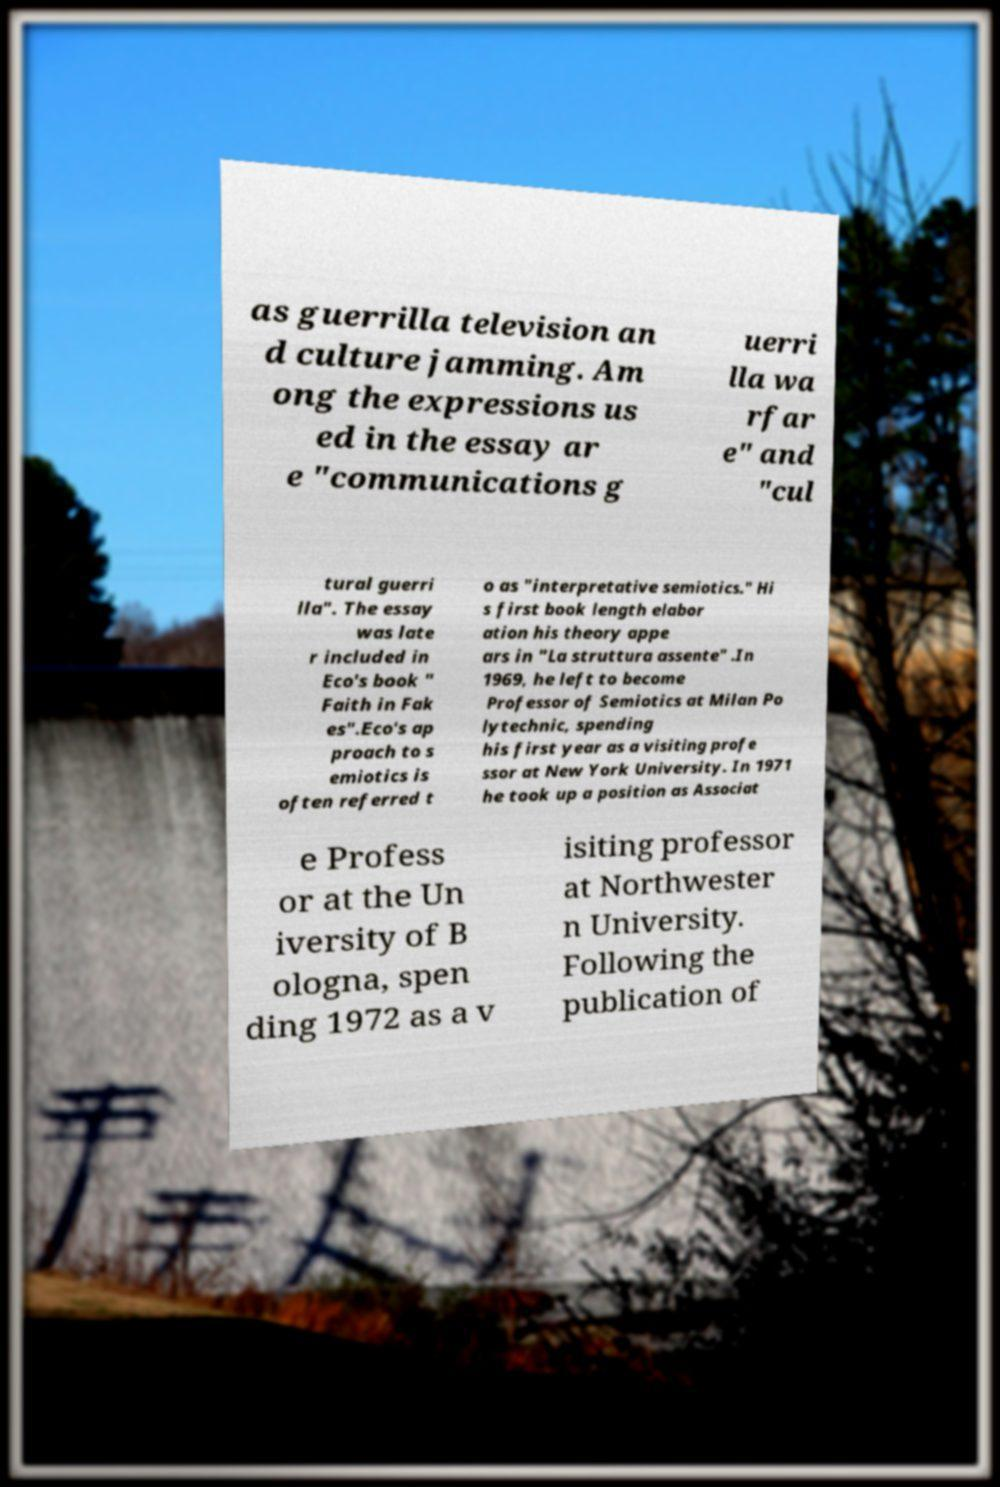I need the written content from this picture converted into text. Can you do that? as guerrilla television an d culture jamming. Am ong the expressions us ed in the essay ar e "communications g uerri lla wa rfar e" and "cul tural guerri lla". The essay was late r included in Eco's book " Faith in Fak es".Eco's ap proach to s emiotics is often referred t o as "interpretative semiotics." Hi s first book length elabor ation his theory appe ars in "La struttura assente" .In 1969, he left to become Professor of Semiotics at Milan Po lytechnic, spending his first year as a visiting profe ssor at New York University. In 1971 he took up a position as Associat e Profess or at the Un iversity of B ologna, spen ding 1972 as a v isiting professor at Northwester n University. Following the publication of 